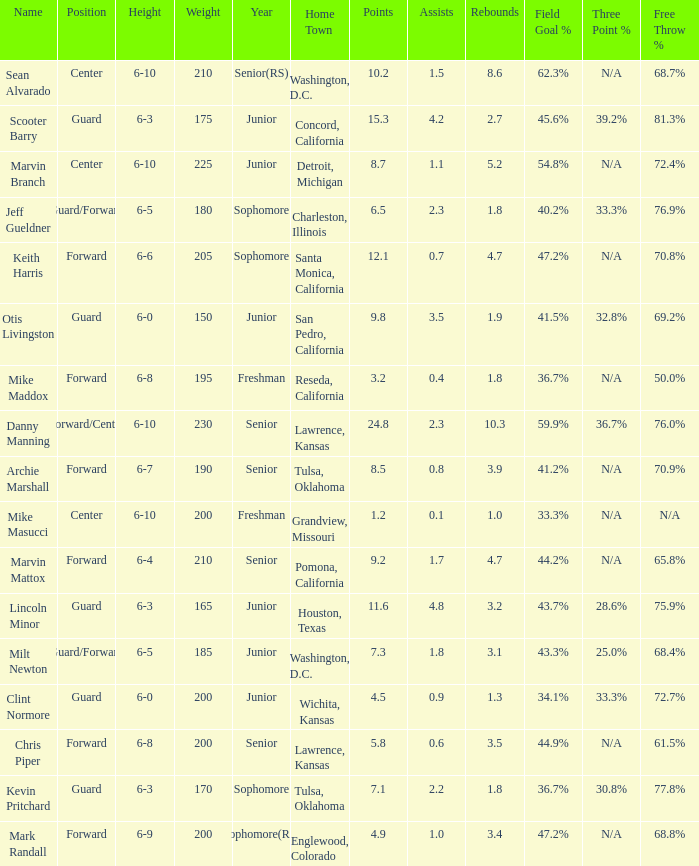Give me the full table as a dictionary. {'header': ['Name', 'Position', 'Height', 'Weight', 'Year', 'Home Town', 'Points', 'Assists', 'Rebounds', 'Field Goal %', 'Three Point %', 'Free Throw %'], 'rows': [['Sean Alvarado', 'Center', '6-10', '210', 'Senior(RS)', 'Washington, D.C.', '10.2', '1.5', '8.6', '62.3%', 'N/A', '68.7%'], ['Scooter Barry', 'Guard', '6-3', '175', 'Junior', 'Concord, California', '15.3', '4.2', '2.7', '45.6%', '39.2%', '81.3%'], ['Marvin Branch', 'Center', '6-10', '225', 'Junior', 'Detroit, Michigan', '8.7', '1.1', '5.2', '54.8%', 'N/A', '72.4%'], ['Jeff Gueldner', 'Guard/Forward', '6-5', '180', 'Sophomore', 'Charleston, Illinois', '6.5', '2.3', '1.8', '40.2%', '33.3%', '76.9%'], ['Keith Harris', 'Forward', '6-6', '205', 'Sophomore', 'Santa Monica, California', '12.1', '0.7', '4.7', '47.2%', 'N/A', '70.8%'], ['Otis Livingston', 'Guard', '6-0', '150', 'Junior', 'San Pedro, California', '9.8', '3.5', '1.9', '41.5%', '32.8%', '69.2%'], ['Mike Maddox', 'Forward', '6-8', '195', 'Freshman', 'Reseda, California', '3.2', '0.4', '1.8', '36.7%', 'N/A', '50.0%'], ['Danny Manning', 'Forward/Center', '6-10', '230', 'Senior', 'Lawrence, Kansas', '24.8', '2.3', '10.3', '59.9%', '36.7%', '76.0%'], ['Archie Marshall', 'Forward', '6-7', '190', 'Senior', 'Tulsa, Oklahoma', '8.5', '0.8', '3.9', '41.2%', 'N/A', '70.9%'], ['Mike Masucci', 'Center', '6-10', '200', 'Freshman', 'Grandview, Missouri', '1.2', '0.1', '1.0', '33.3%', 'N/A', 'N/A'], ['Marvin Mattox', 'Forward', '6-4', '210', 'Senior', 'Pomona, California', '9.2', '1.7', '4.7', '44.2%', 'N/A', '65.8%'], ['Lincoln Minor', 'Guard', '6-3', '165', 'Junior', 'Houston, Texas', '11.6', '4.8', '3.2', '43.7%', '28.6%', '75.9%'], ['Milt Newton', 'Guard/Forward', '6-5', '185', 'Junior', 'Washington, D.C.', '7.3', '1.8', '3.1', '43.3%', '25.0%', '68.4%'], ['Clint Normore', 'Guard', '6-0', '200', 'Junior', 'Wichita, Kansas', '4.5', '0.9', '1.3', '34.1%', '33.3%', '72.7%'], ['Chris Piper', 'Forward', '6-8', '200', 'Senior', 'Lawrence, Kansas', '5.8', '0.6', '3.5', '44.9%', 'N/A', '61.5%'], ['Kevin Pritchard', 'Guard', '6-3', '170', 'Sophomore', 'Tulsa, Oklahoma', '7.1', '2.2', '1.8', '36.7%', '30.8%', '77.8%'], ['Mark Randall', 'Forward', '6-9', '200', 'Sophomore(RS)', 'Englewood, Colorado', '4.9', '1.0', '3.4', '47.2%', 'N/A', '68.8%']]} Can you tell me the average Weight that has Height of 6-9? 200.0. 